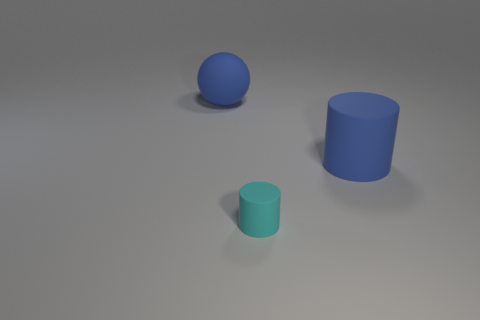Add 3 cyan cylinders. How many objects exist? 6 Subtract all cylinders. How many objects are left? 1 Subtract all blue things. Subtract all blue balls. How many objects are left? 0 Add 2 cyan cylinders. How many cyan cylinders are left? 3 Add 2 small cylinders. How many small cylinders exist? 3 Subtract 0 gray balls. How many objects are left? 3 